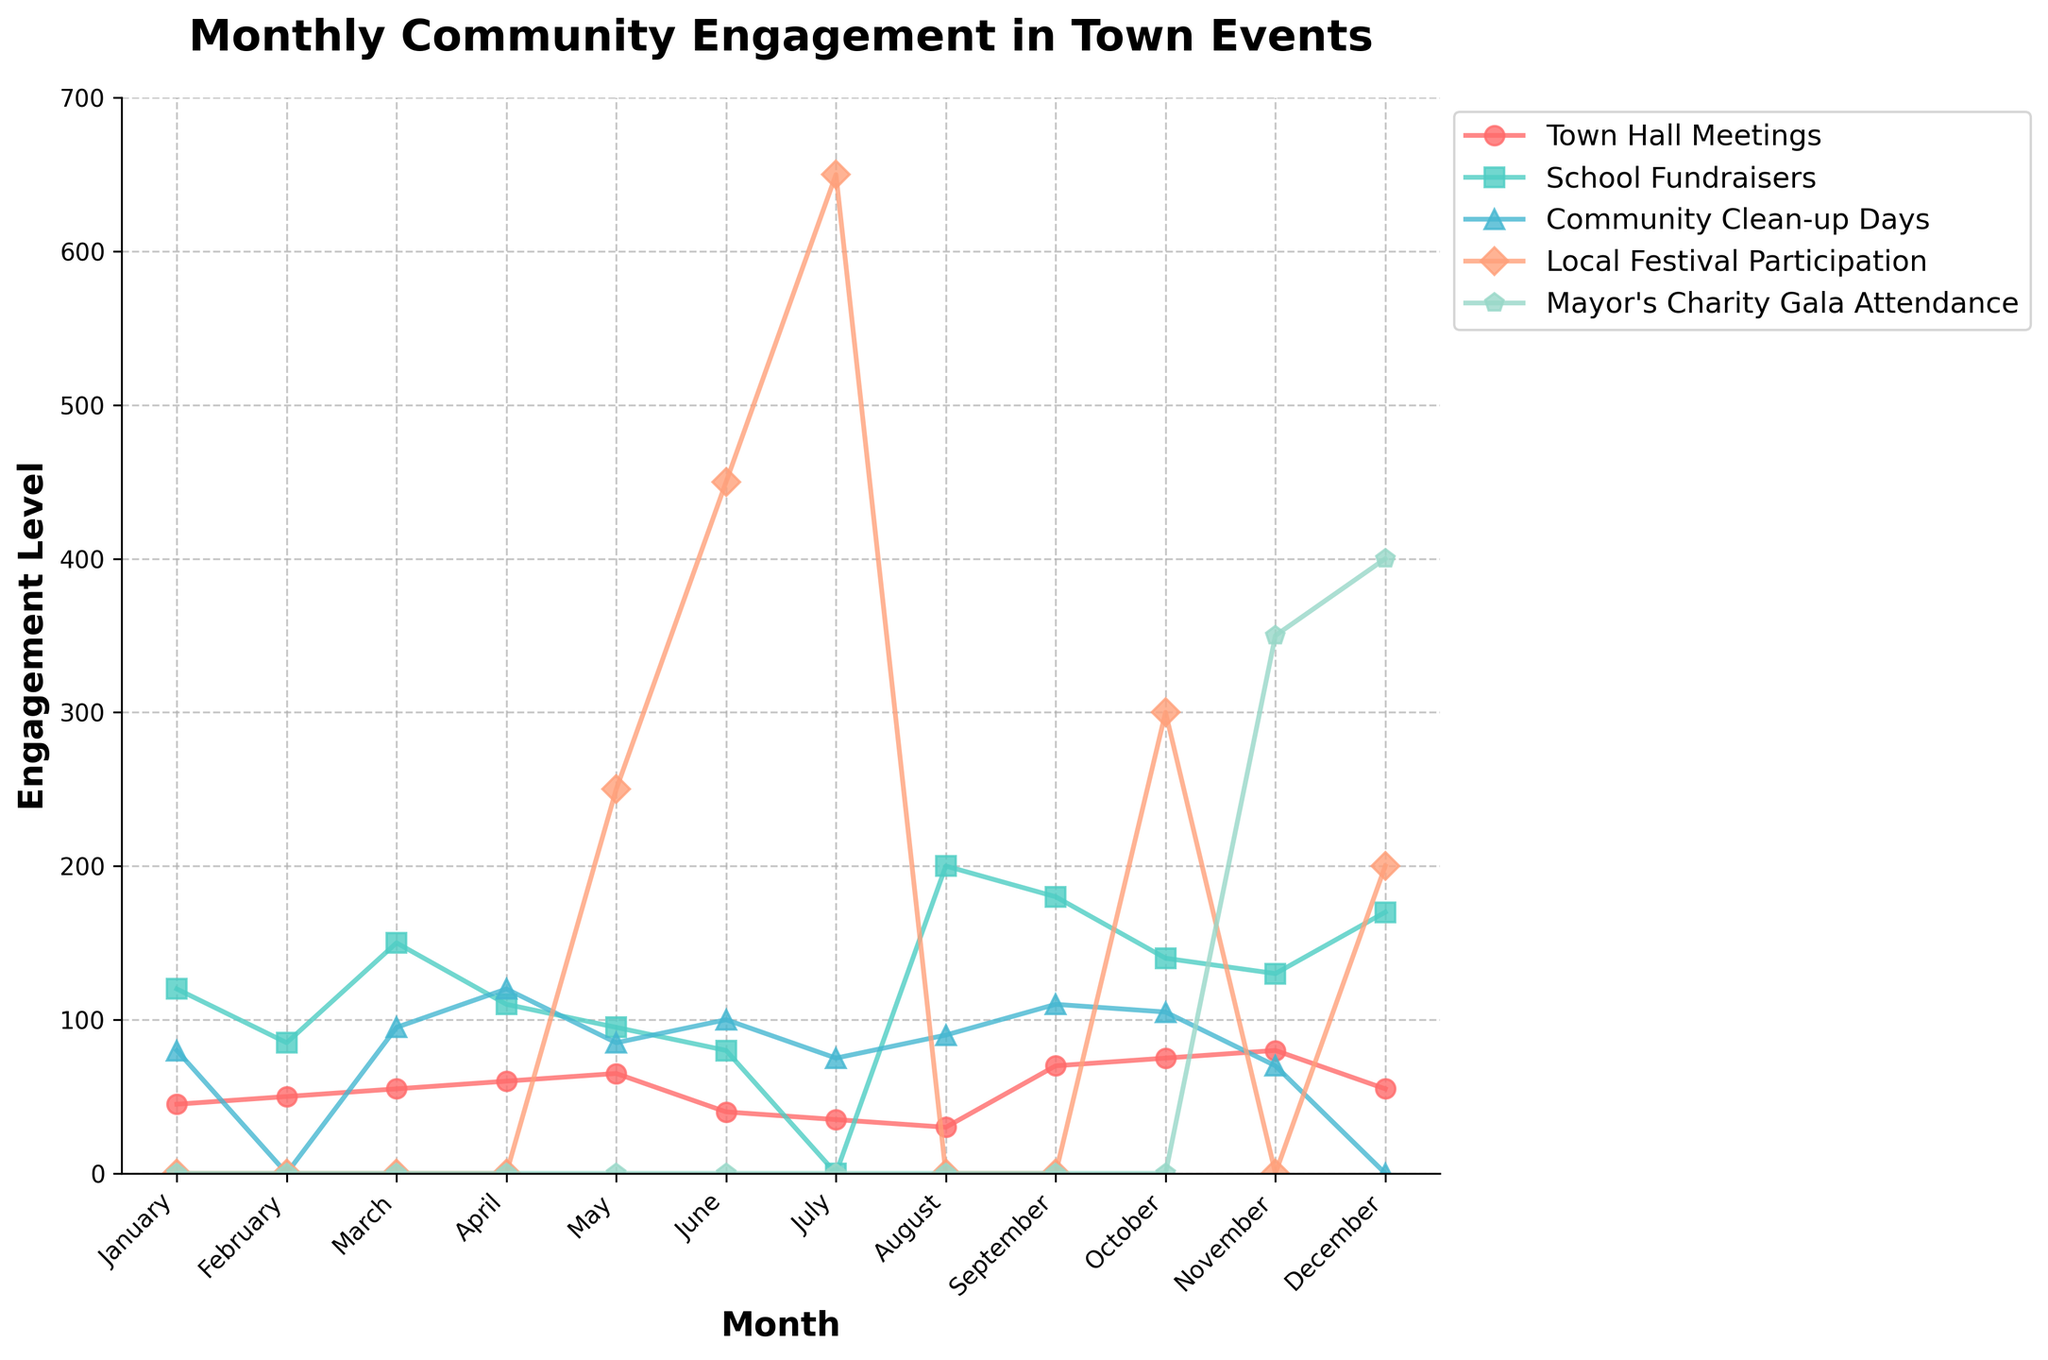How does the participation in School Fundraisers compare between July and August? Look at the heights of the lines representing School Fundraisers marked with squares. In July, the value is 0, whereas in August, it is 200.
Answer: August has higher participation In which month does the Mayor's Charity Gala Attendance peak, and what is the attendance level? Identify the month with the highest point on the line for Mayor's Charity Gala Attendance, marked with pentagons. The peak appears in December with a value of 400.
Answer: December, 400 What was the total community engagement in Local Festival Participation for the months of May, June, and July? Add the values for Local Festival Participation in May (250), June (450), and July (650). 250 + 450 + 650 = 1350.
Answer: 1350 Compare the engagement levels in Town Hall Meetings for April and November. Which one is higher and by how much? The engagement level in April is 60 and in November is 80. The difference is 80 - 60 = 20, and November's value is higher.
Answer: November is higher by 20 What is the trend in engagement levels in Town Hall Meetings from January to June? Observe the plotted points for Town Hall Meetings from January to June. The numbers are 45, 50, 55, 60, 65, and then a drop to 40 in June, indicating an overall increasing trend until May, followed by a drop.
Answer: Increasing until May, then drops in June Which event had zero participation in more than one month? Identify the lines that meet the x-axis at two or more points. Both Community Clean-up Days and Mayor's Charity Gala Attendance have months with zero participation, but only Mayor's Charity Gala Attendance is zero in more than one month (January and February).
Answer: Mayor's Charity Gala Attendance What is the average engagement in School Fundraisers for the entire year? Sum the engagement levels for all months and divide by 12. (120 + 85 + 150 + 110 + 95 + 80 + 0 + 200 + 180 + 140 + 130 + 170) / 12 = 1460 / 12 = 121.67
Answer: 121.67 Which event had the lowest engagement in November and what was its value? Identify the lowest point for November. The values are Town Hall Meetings (80), School Fundraisers (130), Community Clean-up Days (70), Local Festival Participation (0), and Mayor's Charity Gala Attendance (350). Local Festival Participation is the lowest with 0.
Answer: Local Festival Participation, 0 How does the engagement in Community Clean-up Days in March compare to that in September? Compare the heights of the points for Community Clean-up Days in March (95) and September (110). September's engagement level is higher by 15.
Answer: September is higher by 15 